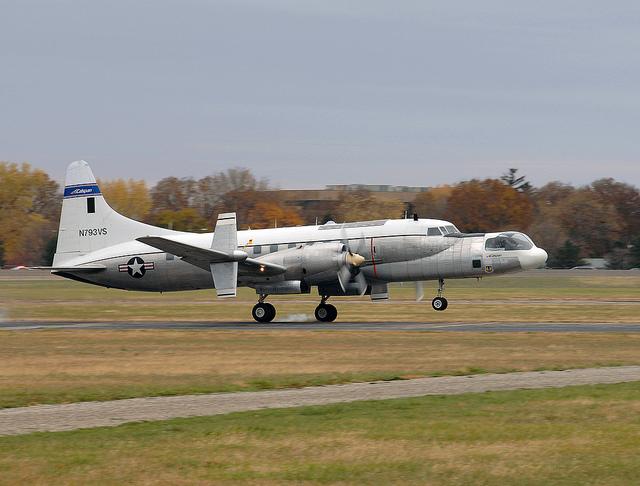Where is a white star?
Be succinct. Plane. Is the plane on the ground?
Answer briefly. Yes. Is this plane safe?
Answer briefly. Yes. 